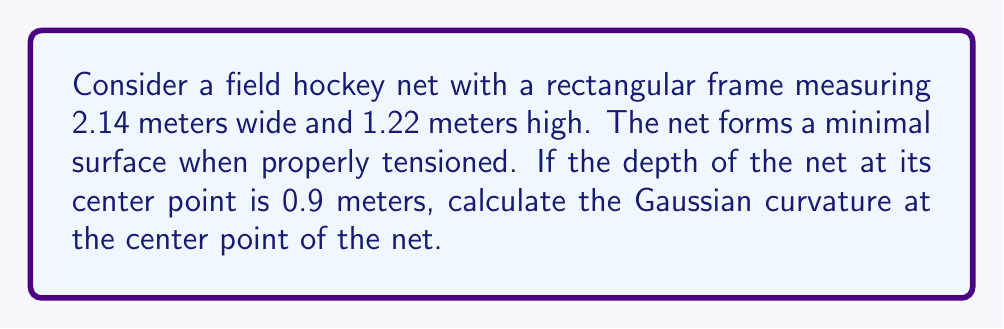Could you help me with this problem? Let's approach this step-by-step:

1) The minimal surface formed by the field hockey net can be approximated by a catenoid, which is a surface of revolution of a catenary curve.

2) The parametric equations for a catenoid are:
   $$x = a \cosh(\frac{z}{a}) \cos(\theta)$$
   $$y = a \cosh(\frac{z}{a}) \sin(\theta)$$
   $$z = z$$

   Where $a$ is a constant that determines the shape of the catenoid.

3) We need to find $a$ using the given dimensions. At the center point, $z = 0.9$ and $x = 1.07$ (half the width of the net). Substituting these into the equation for $x$:

   $$1.07 = a \cosh(\frac{0.9}{a})$$

4) This equation can be solved numerically to find $a \approx 0.9846$.

5) The Gaussian curvature $K$ of a catenoid at any point is given by:
   $$K = -\frac{1}{a^2 \cosh^4(\frac{z}{a})}$$

6) At the center point, $z = 0.9$, so:
   $$K = -\frac{1}{(0.9846)^2 \cosh^4(\frac{0.9}{0.9846})}$$

7) Calculating this:
   $$K \approx -0.2559 \text{ m}^{-2}$$
Answer: $-0.2559 \text{ m}^{-2}$ 